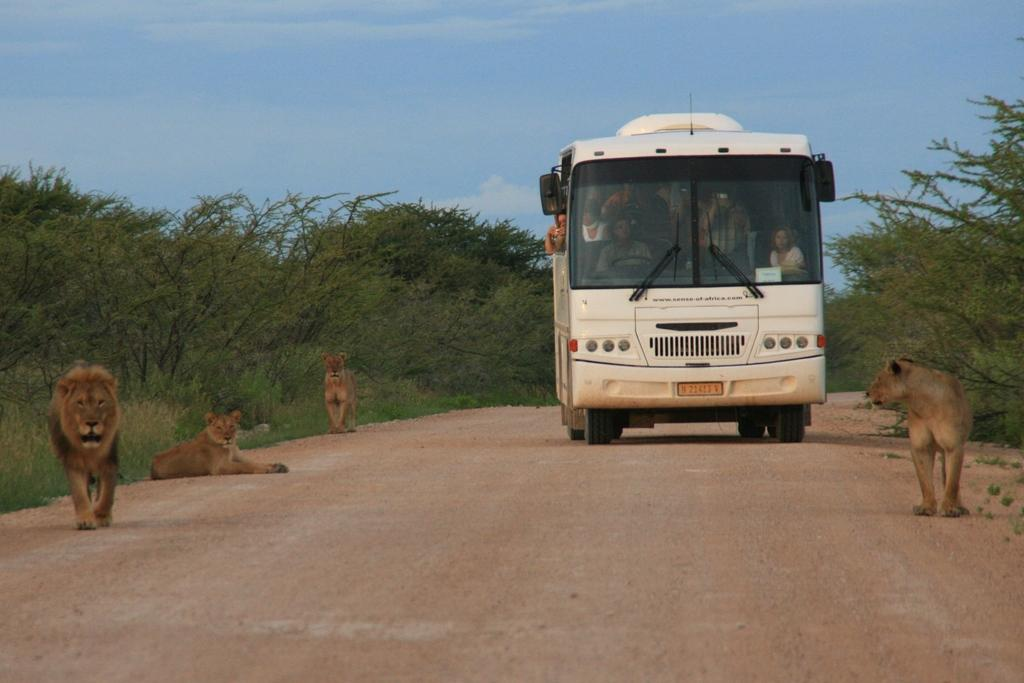What is the main subject of the image? The main subject of the image is a group of people in a bus. What can be seen in front of the bus? There are four lions in front of the bus. What type of vegetation is beside the bus? There is a group of trees beside the bus. What is visible at the top of the image? The sky is visible at the top of the image. Where is the can of paint located in the image? There is no can of paint present in the image. Can you tell me how many family members are in the bus? The image does not provide information about the family relationships of the people in the bus, so it cannot be determined how many family members are present. What type of throne is visible in the image? There is no throne present in the image. 